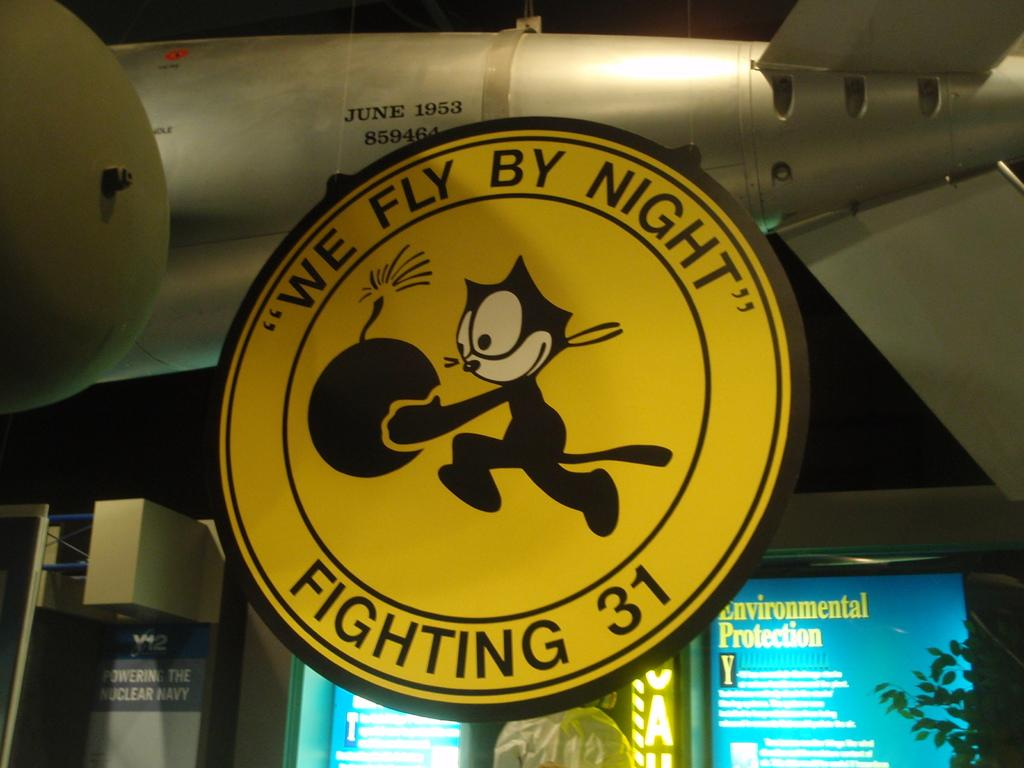<image>
Relay a brief, clear account of the picture shown. A yellow sign hanging from a missal with a picture of a cat carrying a bomb and the slogan "We fly by night". 